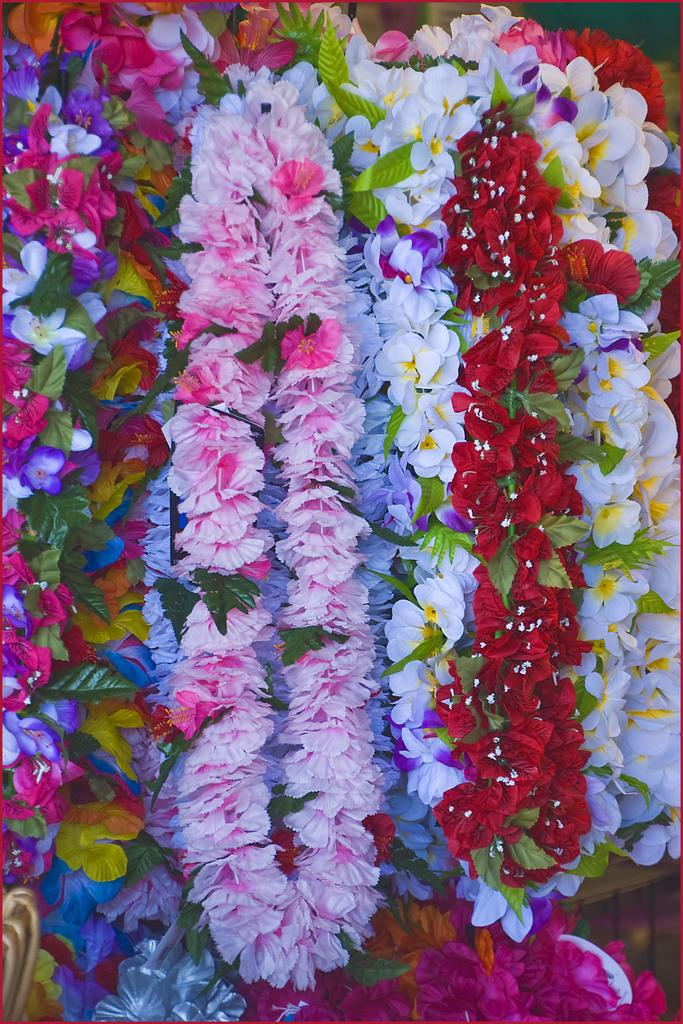What types of decorations are present in the image? There are different types of flower garlands in the image. What color are the leaves in the image? The leaves in the image are green. What type of treatment does the mother receive from her family in the image? There is no mother or family present in the image; it only features flower garlands and green leaves. 